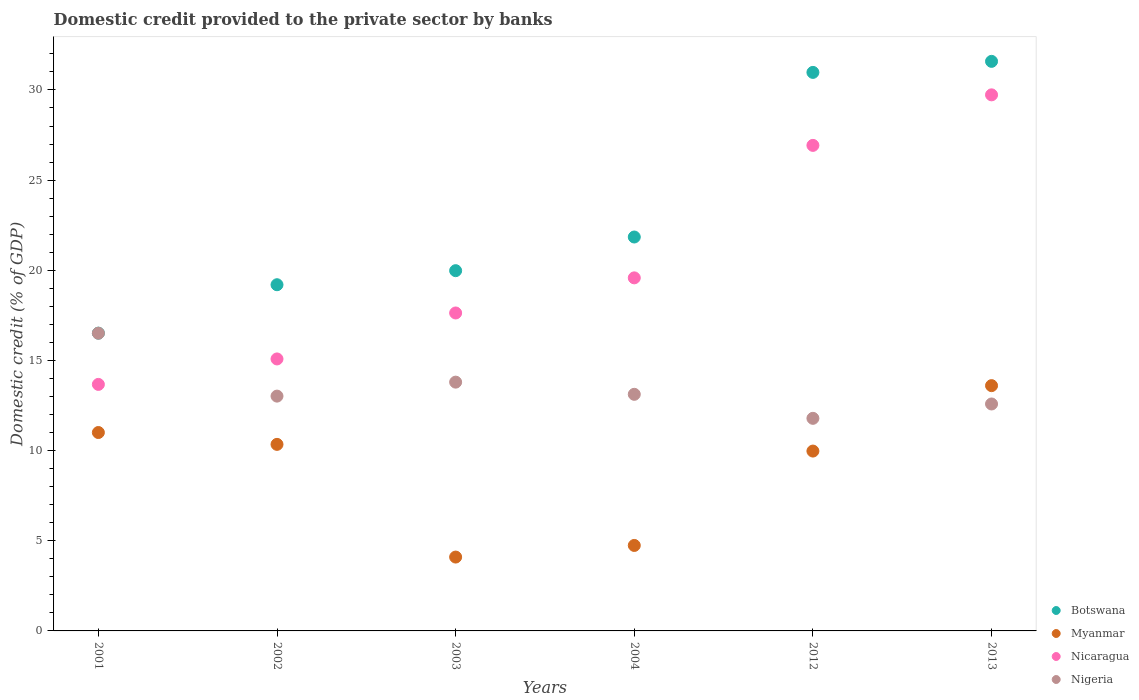Is the number of dotlines equal to the number of legend labels?
Keep it short and to the point. Yes. What is the domestic credit provided to the private sector by banks in Myanmar in 2001?
Provide a short and direct response. 11. Across all years, what is the maximum domestic credit provided to the private sector by banks in Nigeria?
Offer a very short reply. 16.51. Across all years, what is the minimum domestic credit provided to the private sector by banks in Botswana?
Provide a succinct answer. 16.51. In which year was the domestic credit provided to the private sector by banks in Nigeria maximum?
Your answer should be very brief. 2001. What is the total domestic credit provided to the private sector by banks in Nicaragua in the graph?
Your answer should be compact. 122.62. What is the difference between the domestic credit provided to the private sector by banks in Botswana in 2001 and that in 2004?
Your answer should be very brief. -5.33. What is the difference between the domestic credit provided to the private sector by banks in Botswana in 2004 and the domestic credit provided to the private sector by banks in Nicaragua in 2012?
Offer a terse response. -5.08. What is the average domestic credit provided to the private sector by banks in Nicaragua per year?
Your answer should be compact. 20.44. In the year 2001, what is the difference between the domestic credit provided to the private sector by banks in Botswana and domestic credit provided to the private sector by banks in Myanmar?
Provide a short and direct response. 5.51. In how many years, is the domestic credit provided to the private sector by banks in Myanmar greater than 31 %?
Provide a short and direct response. 0. What is the ratio of the domestic credit provided to the private sector by banks in Botswana in 2002 to that in 2003?
Provide a short and direct response. 0.96. Is the difference between the domestic credit provided to the private sector by banks in Botswana in 2004 and 2013 greater than the difference between the domestic credit provided to the private sector by banks in Myanmar in 2004 and 2013?
Ensure brevity in your answer.  No. What is the difference between the highest and the second highest domestic credit provided to the private sector by banks in Nicaragua?
Offer a very short reply. 2.8. What is the difference between the highest and the lowest domestic credit provided to the private sector by banks in Nicaragua?
Offer a terse response. 16.06. Is it the case that in every year, the sum of the domestic credit provided to the private sector by banks in Nigeria and domestic credit provided to the private sector by banks in Myanmar  is greater than the sum of domestic credit provided to the private sector by banks in Nicaragua and domestic credit provided to the private sector by banks in Botswana?
Provide a succinct answer. No. Is it the case that in every year, the sum of the domestic credit provided to the private sector by banks in Nigeria and domestic credit provided to the private sector by banks in Botswana  is greater than the domestic credit provided to the private sector by banks in Nicaragua?
Ensure brevity in your answer.  Yes. Does the domestic credit provided to the private sector by banks in Nicaragua monotonically increase over the years?
Your answer should be very brief. Yes. Is the domestic credit provided to the private sector by banks in Botswana strictly greater than the domestic credit provided to the private sector by banks in Myanmar over the years?
Ensure brevity in your answer.  Yes. Is the domestic credit provided to the private sector by banks in Myanmar strictly less than the domestic credit provided to the private sector by banks in Nigeria over the years?
Provide a short and direct response. No. How many dotlines are there?
Keep it short and to the point. 4. How many years are there in the graph?
Provide a short and direct response. 6. What is the difference between two consecutive major ticks on the Y-axis?
Give a very brief answer. 5. Are the values on the major ticks of Y-axis written in scientific E-notation?
Your response must be concise. No. How many legend labels are there?
Offer a terse response. 4. How are the legend labels stacked?
Your answer should be very brief. Vertical. What is the title of the graph?
Provide a succinct answer. Domestic credit provided to the private sector by banks. Does "American Samoa" appear as one of the legend labels in the graph?
Offer a terse response. No. What is the label or title of the X-axis?
Your answer should be compact. Years. What is the label or title of the Y-axis?
Your answer should be compact. Domestic credit (% of GDP). What is the Domestic credit (% of GDP) of Botswana in 2001?
Provide a succinct answer. 16.51. What is the Domestic credit (% of GDP) of Myanmar in 2001?
Make the answer very short. 11. What is the Domestic credit (% of GDP) in Nicaragua in 2001?
Make the answer very short. 13.67. What is the Domestic credit (% of GDP) of Nigeria in 2001?
Give a very brief answer. 16.51. What is the Domestic credit (% of GDP) of Botswana in 2002?
Provide a succinct answer. 19.2. What is the Domestic credit (% of GDP) in Myanmar in 2002?
Provide a short and direct response. 10.34. What is the Domestic credit (% of GDP) of Nicaragua in 2002?
Offer a terse response. 15.08. What is the Domestic credit (% of GDP) in Nigeria in 2002?
Offer a very short reply. 13.02. What is the Domestic credit (% of GDP) in Botswana in 2003?
Keep it short and to the point. 19.98. What is the Domestic credit (% of GDP) of Myanmar in 2003?
Your answer should be very brief. 4.1. What is the Domestic credit (% of GDP) in Nicaragua in 2003?
Offer a very short reply. 17.63. What is the Domestic credit (% of GDP) in Nigeria in 2003?
Provide a succinct answer. 13.8. What is the Domestic credit (% of GDP) of Botswana in 2004?
Your response must be concise. 21.84. What is the Domestic credit (% of GDP) in Myanmar in 2004?
Your answer should be compact. 4.74. What is the Domestic credit (% of GDP) of Nicaragua in 2004?
Ensure brevity in your answer.  19.58. What is the Domestic credit (% of GDP) in Nigeria in 2004?
Provide a short and direct response. 13.12. What is the Domestic credit (% of GDP) of Botswana in 2012?
Ensure brevity in your answer.  30.97. What is the Domestic credit (% of GDP) in Myanmar in 2012?
Your response must be concise. 9.97. What is the Domestic credit (% of GDP) in Nicaragua in 2012?
Ensure brevity in your answer.  26.93. What is the Domestic credit (% of GDP) of Nigeria in 2012?
Give a very brief answer. 11.79. What is the Domestic credit (% of GDP) in Botswana in 2013?
Your answer should be very brief. 31.58. What is the Domestic credit (% of GDP) in Myanmar in 2013?
Your answer should be very brief. 13.6. What is the Domestic credit (% of GDP) of Nicaragua in 2013?
Keep it short and to the point. 29.73. What is the Domestic credit (% of GDP) in Nigeria in 2013?
Your response must be concise. 12.59. Across all years, what is the maximum Domestic credit (% of GDP) in Botswana?
Offer a very short reply. 31.58. Across all years, what is the maximum Domestic credit (% of GDP) in Myanmar?
Your response must be concise. 13.6. Across all years, what is the maximum Domestic credit (% of GDP) in Nicaragua?
Offer a very short reply. 29.73. Across all years, what is the maximum Domestic credit (% of GDP) in Nigeria?
Give a very brief answer. 16.51. Across all years, what is the minimum Domestic credit (% of GDP) of Botswana?
Provide a succinct answer. 16.51. Across all years, what is the minimum Domestic credit (% of GDP) of Myanmar?
Keep it short and to the point. 4.1. Across all years, what is the minimum Domestic credit (% of GDP) in Nicaragua?
Provide a short and direct response. 13.67. Across all years, what is the minimum Domestic credit (% of GDP) in Nigeria?
Ensure brevity in your answer.  11.79. What is the total Domestic credit (% of GDP) of Botswana in the graph?
Your answer should be compact. 140.09. What is the total Domestic credit (% of GDP) of Myanmar in the graph?
Ensure brevity in your answer.  53.76. What is the total Domestic credit (% of GDP) of Nicaragua in the graph?
Your answer should be compact. 122.62. What is the total Domestic credit (% of GDP) in Nigeria in the graph?
Provide a succinct answer. 80.82. What is the difference between the Domestic credit (% of GDP) of Botswana in 2001 and that in 2002?
Your answer should be very brief. -2.69. What is the difference between the Domestic credit (% of GDP) in Myanmar in 2001 and that in 2002?
Provide a succinct answer. 0.66. What is the difference between the Domestic credit (% of GDP) of Nicaragua in 2001 and that in 2002?
Give a very brief answer. -1.41. What is the difference between the Domestic credit (% of GDP) in Nigeria in 2001 and that in 2002?
Ensure brevity in your answer.  3.49. What is the difference between the Domestic credit (% of GDP) in Botswana in 2001 and that in 2003?
Your response must be concise. -3.47. What is the difference between the Domestic credit (% of GDP) of Myanmar in 2001 and that in 2003?
Make the answer very short. 6.91. What is the difference between the Domestic credit (% of GDP) of Nicaragua in 2001 and that in 2003?
Make the answer very short. -3.96. What is the difference between the Domestic credit (% of GDP) of Nigeria in 2001 and that in 2003?
Give a very brief answer. 2.71. What is the difference between the Domestic credit (% of GDP) in Botswana in 2001 and that in 2004?
Keep it short and to the point. -5.33. What is the difference between the Domestic credit (% of GDP) of Myanmar in 2001 and that in 2004?
Provide a short and direct response. 6.26. What is the difference between the Domestic credit (% of GDP) in Nicaragua in 2001 and that in 2004?
Give a very brief answer. -5.91. What is the difference between the Domestic credit (% of GDP) of Nigeria in 2001 and that in 2004?
Your response must be concise. 3.39. What is the difference between the Domestic credit (% of GDP) of Botswana in 2001 and that in 2012?
Keep it short and to the point. -14.46. What is the difference between the Domestic credit (% of GDP) in Myanmar in 2001 and that in 2012?
Your answer should be very brief. 1.03. What is the difference between the Domestic credit (% of GDP) in Nicaragua in 2001 and that in 2012?
Ensure brevity in your answer.  -13.25. What is the difference between the Domestic credit (% of GDP) in Nigeria in 2001 and that in 2012?
Your answer should be very brief. 4.72. What is the difference between the Domestic credit (% of GDP) of Botswana in 2001 and that in 2013?
Your answer should be very brief. -15.07. What is the difference between the Domestic credit (% of GDP) in Myanmar in 2001 and that in 2013?
Your answer should be compact. -2.6. What is the difference between the Domestic credit (% of GDP) of Nicaragua in 2001 and that in 2013?
Offer a terse response. -16.06. What is the difference between the Domestic credit (% of GDP) of Nigeria in 2001 and that in 2013?
Keep it short and to the point. 3.92. What is the difference between the Domestic credit (% of GDP) in Botswana in 2002 and that in 2003?
Your answer should be compact. -0.78. What is the difference between the Domestic credit (% of GDP) of Myanmar in 2002 and that in 2003?
Give a very brief answer. 6.25. What is the difference between the Domestic credit (% of GDP) in Nicaragua in 2002 and that in 2003?
Offer a terse response. -2.55. What is the difference between the Domestic credit (% of GDP) of Nigeria in 2002 and that in 2003?
Your answer should be compact. -0.78. What is the difference between the Domestic credit (% of GDP) in Botswana in 2002 and that in 2004?
Offer a terse response. -2.65. What is the difference between the Domestic credit (% of GDP) in Myanmar in 2002 and that in 2004?
Make the answer very short. 5.6. What is the difference between the Domestic credit (% of GDP) of Nicaragua in 2002 and that in 2004?
Your answer should be compact. -4.5. What is the difference between the Domestic credit (% of GDP) of Nigeria in 2002 and that in 2004?
Your answer should be compact. -0.1. What is the difference between the Domestic credit (% of GDP) in Botswana in 2002 and that in 2012?
Provide a short and direct response. -11.77. What is the difference between the Domestic credit (% of GDP) in Myanmar in 2002 and that in 2012?
Your answer should be very brief. 0.37. What is the difference between the Domestic credit (% of GDP) in Nicaragua in 2002 and that in 2012?
Offer a terse response. -11.84. What is the difference between the Domestic credit (% of GDP) in Nigeria in 2002 and that in 2012?
Offer a very short reply. 1.23. What is the difference between the Domestic credit (% of GDP) in Botswana in 2002 and that in 2013?
Provide a short and direct response. -12.39. What is the difference between the Domestic credit (% of GDP) in Myanmar in 2002 and that in 2013?
Ensure brevity in your answer.  -3.26. What is the difference between the Domestic credit (% of GDP) in Nicaragua in 2002 and that in 2013?
Ensure brevity in your answer.  -14.64. What is the difference between the Domestic credit (% of GDP) in Nigeria in 2002 and that in 2013?
Provide a short and direct response. 0.44. What is the difference between the Domestic credit (% of GDP) of Botswana in 2003 and that in 2004?
Give a very brief answer. -1.87. What is the difference between the Domestic credit (% of GDP) of Myanmar in 2003 and that in 2004?
Your response must be concise. -0.64. What is the difference between the Domestic credit (% of GDP) of Nicaragua in 2003 and that in 2004?
Your response must be concise. -1.95. What is the difference between the Domestic credit (% of GDP) in Nigeria in 2003 and that in 2004?
Offer a terse response. 0.68. What is the difference between the Domestic credit (% of GDP) of Botswana in 2003 and that in 2012?
Keep it short and to the point. -11. What is the difference between the Domestic credit (% of GDP) in Myanmar in 2003 and that in 2012?
Your response must be concise. -5.88. What is the difference between the Domestic credit (% of GDP) in Nicaragua in 2003 and that in 2012?
Keep it short and to the point. -9.29. What is the difference between the Domestic credit (% of GDP) of Nigeria in 2003 and that in 2012?
Your answer should be compact. 2.01. What is the difference between the Domestic credit (% of GDP) of Botswana in 2003 and that in 2013?
Give a very brief answer. -11.61. What is the difference between the Domestic credit (% of GDP) of Myanmar in 2003 and that in 2013?
Your answer should be compact. -9.51. What is the difference between the Domestic credit (% of GDP) in Nicaragua in 2003 and that in 2013?
Offer a terse response. -12.1. What is the difference between the Domestic credit (% of GDP) in Nigeria in 2003 and that in 2013?
Make the answer very short. 1.21. What is the difference between the Domestic credit (% of GDP) of Botswana in 2004 and that in 2012?
Your answer should be very brief. -9.13. What is the difference between the Domestic credit (% of GDP) in Myanmar in 2004 and that in 2012?
Your response must be concise. -5.23. What is the difference between the Domestic credit (% of GDP) of Nicaragua in 2004 and that in 2012?
Make the answer very short. -7.35. What is the difference between the Domestic credit (% of GDP) of Nigeria in 2004 and that in 2012?
Provide a short and direct response. 1.33. What is the difference between the Domestic credit (% of GDP) of Botswana in 2004 and that in 2013?
Your answer should be compact. -9.74. What is the difference between the Domestic credit (% of GDP) of Myanmar in 2004 and that in 2013?
Ensure brevity in your answer.  -8.86. What is the difference between the Domestic credit (% of GDP) of Nicaragua in 2004 and that in 2013?
Your answer should be compact. -10.15. What is the difference between the Domestic credit (% of GDP) in Nigeria in 2004 and that in 2013?
Your response must be concise. 0.54. What is the difference between the Domestic credit (% of GDP) of Botswana in 2012 and that in 2013?
Provide a short and direct response. -0.61. What is the difference between the Domestic credit (% of GDP) in Myanmar in 2012 and that in 2013?
Your answer should be compact. -3.63. What is the difference between the Domestic credit (% of GDP) of Nicaragua in 2012 and that in 2013?
Keep it short and to the point. -2.8. What is the difference between the Domestic credit (% of GDP) of Nigeria in 2012 and that in 2013?
Your answer should be very brief. -0.8. What is the difference between the Domestic credit (% of GDP) of Botswana in 2001 and the Domestic credit (% of GDP) of Myanmar in 2002?
Provide a short and direct response. 6.17. What is the difference between the Domestic credit (% of GDP) in Botswana in 2001 and the Domestic credit (% of GDP) in Nicaragua in 2002?
Offer a very short reply. 1.43. What is the difference between the Domestic credit (% of GDP) of Botswana in 2001 and the Domestic credit (% of GDP) of Nigeria in 2002?
Offer a terse response. 3.49. What is the difference between the Domestic credit (% of GDP) of Myanmar in 2001 and the Domestic credit (% of GDP) of Nicaragua in 2002?
Make the answer very short. -4.08. What is the difference between the Domestic credit (% of GDP) in Myanmar in 2001 and the Domestic credit (% of GDP) in Nigeria in 2002?
Offer a very short reply. -2.02. What is the difference between the Domestic credit (% of GDP) of Nicaragua in 2001 and the Domestic credit (% of GDP) of Nigeria in 2002?
Offer a very short reply. 0.65. What is the difference between the Domestic credit (% of GDP) of Botswana in 2001 and the Domestic credit (% of GDP) of Myanmar in 2003?
Offer a very short reply. 12.42. What is the difference between the Domestic credit (% of GDP) in Botswana in 2001 and the Domestic credit (% of GDP) in Nicaragua in 2003?
Offer a very short reply. -1.12. What is the difference between the Domestic credit (% of GDP) of Botswana in 2001 and the Domestic credit (% of GDP) of Nigeria in 2003?
Offer a very short reply. 2.72. What is the difference between the Domestic credit (% of GDP) in Myanmar in 2001 and the Domestic credit (% of GDP) in Nicaragua in 2003?
Provide a short and direct response. -6.63. What is the difference between the Domestic credit (% of GDP) of Myanmar in 2001 and the Domestic credit (% of GDP) of Nigeria in 2003?
Your response must be concise. -2.79. What is the difference between the Domestic credit (% of GDP) of Nicaragua in 2001 and the Domestic credit (% of GDP) of Nigeria in 2003?
Give a very brief answer. -0.13. What is the difference between the Domestic credit (% of GDP) of Botswana in 2001 and the Domestic credit (% of GDP) of Myanmar in 2004?
Ensure brevity in your answer.  11.77. What is the difference between the Domestic credit (% of GDP) in Botswana in 2001 and the Domestic credit (% of GDP) in Nicaragua in 2004?
Offer a very short reply. -3.07. What is the difference between the Domestic credit (% of GDP) in Botswana in 2001 and the Domestic credit (% of GDP) in Nigeria in 2004?
Offer a very short reply. 3.39. What is the difference between the Domestic credit (% of GDP) of Myanmar in 2001 and the Domestic credit (% of GDP) of Nicaragua in 2004?
Make the answer very short. -8.58. What is the difference between the Domestic credit (% of GDP) of Myanmar in 2001 and the Domestic credit (% of GDP) of Nigeria in 2004?
Make the answer very short. -2.12. What is the difference between the Domestic credit (% of GDP) of Nicaragua in 2001 and the Domestic credit (% of GDP) of Nigeria in 2004?
Your answer should be compact. 0.55. What is the difference between the Domestic credit (% of GDP) of Botswana in 2001 and the Domestic credit (% of GDP) of Myanmar in 2012?
Make the answer very short. 6.54. What is the difference between the Domestic credit (% of GDP) in Botswana in 2001 and the Domestic credit (% of GDP) in Nicaragua in 2012?
Keep it short and to the point. -10.41. What is the difference between the Domestic credit (% of GDP) of Botswana in 2001 and the Domestic credit (% of GDP) of Nigeria in 2012?
Your answer should be compact. 4.72. What is the difference between the Domestic credit (% of GDP) in Myanmar in 2001 and the Domestic credit (% of GDP) in Nicaragua in 2012?
Provide a short and direct response. -15.92. What is the difference between the Domestic credit (% of GDP) of Myanmar in 2001 and the Domestic credit (% of GDP) of Nigeria in 2012?
Offer a terse response. -0.79. What is the difference between the Domestic credit (% of GDP) of Nicaragua in 2001 and the Domestic credit (% of GDP) of Nigeria in 2012?
Offer a terse response. 1.88. What is the difference between the Domestic credit (% of GDP) in Botswana in 2001 and the Domestic credit (% of GDP) in Myanmar in 2013?
Offer a terse response. 2.91. What is the difference between the Domestic credit (% of GDP) of Botswana in 2001 and the Domestic credit (% of GDP) of Nicaragua in 2013?
Provide a succinct answer. -13.22. What is the difference between the Domestic credit (% of GDP) in Botswana in 2001 and the Domestic credit (% of GDP) in Nigeria in 2013?
Offer a terse response. 3.93. What is the difference between the Domestic credit (% of GDP) in Myanmar in 2001 and the Domestic credit (% of GDP) in Nicaragua in 2013?
Keep it short and to the point. -18.73. What is the difference between the Domestic credit (% of GDP) of Myanmar in 2001 and the Domestic credit (% of GDP) of Nigeria in 2013?
Ensure brevity in your answer.  -1.58. What is the difference between the Domestic credit (% of GDP) of Nicaragua in 2001 and the Domestic credit (% of GDP) of Nigeria in 2013?
Offer a terse response. 1.09. What is the difference between the Domestic credit (% of GDP) in Botswana in 2002 and the Domestic credit (% of GDP) in Myanmar in 2003?
Your answer should be very brief. 15.1. What is the difference between the Domestic credit (% of GDP) in Botswana in 2002 and the Domestic credit (% of GDP) in Nicaragua in 2003?
Provide a short and direct response. 1.57. What is the difference between the Domestic credit (% of GDP) of Botswana in 2002 and the Domestic credit (% of GDP) of Nigeria in 2003?
Make the answer very short. 5.4. What is the difference between the Domestic credit (% of GDP) in Myanmar in 2002 and the Domestic credit (% of GDP) in Nicaragua in 2003?
Ensure brevity in your answer.  -7.29. What is the difference between the Domestic credit (% of GDP) in Myanmar in 2002 and the Domestic credit (% of GDP) in Nigeria in 2003?
Provide a succinct answer. -3.45. What is the difference between the Domestic credit (% of GDP) of Nicaragua in 2002 and the Domestic credit (% of GDP) of Nigeria in 2003?
Offer a terse response. 1.29. What is the difference between the Domestic credit (% of GDP) in Botswana in 2002 and the Domestic credit (% of GDP) in Myanmar in 2004?
Keep it short and to the point. 14.46. What is the difference between the Domestic credit (% of GDP) in Botswana in 2002 and the Domestic credit (% of GDP) in Nicaragua in 2004?
Make the answer very short. -0.38. What is the difference between the Domestic credit (% of GDP) in Botswana in 2002 and the Domestic credit (% of GDP) in Nigeria in 2004?
Ensure brevity in your answer.  6.08. What is the difference between the Domestic credit (% of GDP) in Myanmar in 2002 and the Domestic credit (% of GDP) in Nicaragua in 2004?
Ensure brevity in your answer.  -9.23. What is the difference between the Domestic credit (% of GDP) of Myanmar in 2002 and the Domestic credit (% of GDP) of Nigeria in 2004?
Ensure brevity in your answer.  -2.78. What is the difference between the Domestic credit (% of GDP) in Nicaragua in 2002 and the Domestic credit (% of GDP) in Nigeria in 2004?
Offer a very short reply. 1.96. What is the difference between the Domestic credit (% of GDP) of Botswana in 2002 and the Domestic credit (% of GDP) of Myanmar in 2012?
Provide a succinct answer. 9.22. What is the difference between the Domestic credit (% of GDP) in Botswana in 2002 and the Domestic credit (% of GDP) in Nicaragua in 2012?
Your answer should be very brief. -7.73. What is the difference between the Domestic credit (% of GDP) in Botswana in 2002 and the Domestic credit (% of GDP) in Nigeria in 2012?
Your response must be concise. 7.41. What is the difference between the Domestic credit (% of GDP) of Myanmar in 2002 and the Domestic credit (% of GDP) of Nicaragua in 2012?
Provide a succinct answer. -16.58. What is the difference between the Domestic credit (% of GDP) in Myanmar in 2002 and the Domestic credit (% of GDP) in Nigeria in 2012?
Provide a short and direct response. -1.44. What is the difference between the Domestic credit (% of GDP) in Nicaragua in 2002 and the Domestic credit (% of GDP) in Nigeria in 2012?
Provide a short and direct response. 3.29. What is the difference between the Domestic credit (% of GDP) of Botswana in 2002 and the Domestic credit (% of GDP) of Myanmar in 2013?
Offer a terse response. 5.6. What is the difference between the Domestic credit (% of GDP) in Botswana in 2002 and the Domestic credit (% of GDP) in Nicaragua in 2013?
Offer a very short reply. -10.53. What is the difference between the Domestic credit (% of GDP) of Botswana in 2002 and the Domestic credit (% of GDP) of Nigeria in 2013?
Keep it short and to the point. 6.61. What is the difference between the Domestic credit (% of GDP) in Myanmar in 2002 and the Domestic credit (% of GDP) in Nicaragua in 2013?
Your answer should be very brief. -19.38. What is the difference between the Domestic credit (% of GDP) of Myanmar in 2002 and the Domestic credit (% of GDP) of Nigeria in 2013?
Provide a succinct answer. -2.24. What is the difference between the Domestic credit (% of GDP) of Nicaragua in 2002 and the Domestic credit (% of GDP) of Nigeria in 2013?
Provide a succinct answer. 2.5. What is the difference between the Domestic credit (% of GDP) in Botswana in 2003 and the Domestic credit (% of GDP) in Myanmar in 2004?
Your answer should be very brief. 15.24. What is the difference between the Domestic credit (% of GDP) of Botswana in 2003 and the Domestic credit (% of GDP) of Nicaragua in 2004?
Provide a short and direct response. 0.4. What is the difference between the Domestic credit (% of GDP) of Botswana in 2003 and the Domestic credit (% of GDP) of Nigeria in 2004?
Your response must be concise. 6.86. What is the difference between the Domestic credit (% of GDP) in Myanmar in 2003 and the Domestic credit (% of GDP) in Nicaragua in 2004?
Offer a very short reply. -15.48. What is the difference between the Domestic credit (% of GDP) in Myanmar in 2003 and the Domestic credit (% of GDP) in Nigeria in 2004?
Keep it short and to the point. -9.03. What is the difference between the Domestic credit (% of GDP) in Nicaragua in 2003 and the Domestic credit (% of GDP) in Nigeria in 2004?
Ensure brevity in your answer.  4.51. What is the difference between the Domestic credit (% of GDP) in Botswana in 2003 and the Domestic credit (% of GDP) in Myanmar in 2012?
Your response must be concise. 10. What is the difference between the Domestic credit (% of GDP) in Botswana in 2003 and the Domestic credit (% of GDP) in Nicaragua in 2012?
Provide a short and direct response. -6.95. What is the difference between the Domestic credit (% of GDP) of Botswana in 2003 and the Domestic credit (% of GDP) of Nigeria in 2012?
Keep it short and to the point. 8.19. What is the difference between the Domestic credit (% of GDP) of Myanmar in 2003 and the Domestic credit (% of GDP) of Nicaragua in 2012?
Your answer should be compact. -22.83. What is the difference between the Domestic credit (% of GDP) in Myanmar in 2003 and the Domestic credit (% of GDP) in Nigeria in 2012?
Provide a short and direct response. -7.69. What is the difference between the Domestic credit (% of GDP) in Nicaragua in 2003 and the Domestic credit (% of GDP) in Nigeria in 2012?
Provide a short and direct response. 5.84. What is the difference between the Domestic credit (% of GDP) of Botswana in 2003 and the Domestic credit (% of GDP) of Myanmar in 2013?
Keep it short and to the point. 6.38. What is the difference between the Domestic credit (% of GDP) in Botswana in 2003 and the Domestic credit (% of GDP) in Nicaragua in 2013?
Make the answer very short. -9.75. What is the difference between the Domestic credit (% of GDP) of Botswana in 2003 and the Domestic credit (% of GDP) of Nigeria in 2013?
Make the answer very short. 7.39. What is the difference between the Domestic credit (% of GDP) of Myanmar in 2003 and the Domestic credit (% of GDP) of Nicaragua in 2013?
Keep it short and to the point. -25.63. What is the difference between the Domestic credit (% of GDP) of Myanmar in 2003 and the Domestic credit (% of GDP) of Nigeria in 2013?
Provide a succinct answer. -8.49. What is the difference between the Domestic credit (% of GDP) of Nicaragua in 2003 and the Domestic credit (% of GDP) of Nigeria in 2013?
Provide a short and direct response. 5.05. What is the difference between the Domestic credit (% of GDP) in Botswana in 2004 and the Domestic credit (% of GDP) in Myanmar in 2012?
Provide a succinct answer. 11.87. What is the difference between the Domestic credit (% of GDP) in Botswana in 2004 and the Domestic credit (% of GDP) in Nicaragua in 2012?
Your answer should be very brief. -5.08. What is the difference between the Domestic credit (% of GDP) of Botswana in 2004 and the Domestic credit (% of GDP) of Nigeria in 2012?
Give a very brief answer. 10.06. What is the difference between the Domestic credit (% of GDP) in Myanmar in 2004 and the Domestic credit (% of GDP) in Nicaragua in 2012?
Your answer should be compact. -22.19. What is the difference between the Domestic credit (% of GDP) in Myanmar in 2004 and the Domestic credit (% of GDP) in Nigeria in 2012?
Ensure brevity in your answer.  -7.05. What is the difference between the Domestic credit (% of GDP) in Nicaragua in 2004 and the Domestic credit (% of GDP) in Nigeria in 2012?
Offer a very short reply. 7.79. What is the difference between the Domestic credit (% of GDP) in Botswana in 2004 and the Domestic credit (% of GDP) in Myanmar in 2013?
Your response must be concise. 8.24. What is the difference between the Domestic credit (% of GDP) in Botswana in 2004 and the Domestic credit (% of GDP) in Nicaragua in 2013?
Make the answer very short. -7.88. What is the difference between the Domestic credit (% of GDP) in Botswana in 2004 and the Domestic credit (% of GDP) in Nigeria in 2013?
Ensure brevity in your answer.  9.26. What is the difference between the Domestic credit (% of GDP) of Myanmar in 2004 and the Domestic credit (% of GDP) of Nicaragua in 2013?
Ensure brevity in your answer.  -24.99. What is the difference between the Domestic credit (% of GDP) of Myanmar in 2004 and the Domestic credit (% of GDP) of Nigeria in 2013?
Make the answer very short. -7.85. What is the difference between the Domestic credit (% of GDP) of Nicaragua in 2004 and the Domestic credit (% of GDP) of Nigeria in 2013?
Give a very brief answer. 6.99. What is the difference between the Domestic credit (% of GDP) in Botswana in 2012 and the Domestic credit (% of GDP) in Myanmar in 2013?
Give a very brief answer. 17.37. What is the difference between the Domestic credit (% of GDP) in Botswana in 2012 and the Domestic credit (% of GDP) in Nicaragua in 2013?
Your answer should be compact. 1.25. What is the difference between the Domestic credit (% of GDP) in Botswana in 2012 and the Domestic credit (% of GDP) in Nigeria in 2013?
Your answer should be compact. 18.39. What is the difference between the Domestic credit (% of GDP) in Myanmar in 2012 and the Domestic credit (% of GDP) in Nicaragua in 2013?
Your response must be concise. -19.75. What is the difference between the Domestic credit (% of GDP) of Myanmar in 2012 and the Domestic credit (% of GDP) of Nigeria in 2013?
Your answer should be compact. -2.61. What is the difference between the Domestic credit (% of GDP) in Nicaragua in 2012 and the Domestic credit (% of GDP) in Nigeria in 2013?
Keep it short and to the point. 14.34. What is the average Domestic credit (% of GDP) of Botswana per year?
Offer a very short reply. 23.35. What is the average Domestic credit (% of GDP) of Myanmar per year?
Keep it short and to the point. 8.96. What is the average Domestic credit (% of GDP) of Nicaragua per year?
Your response must be concise. 20.44. What is the average Domestic credit (% of GDP) of Nigeria per year?
Ensure brevity in your answer.  13.47. In the year 2001, what is the difference between the Domestic credit (% of GDP) in Botswana and Domestic credit (% of GDP) in Myanmar?
Keep it short and to the point. 5.51. In the year 2001, what is the difference between the Domestic credit (% of GDP) of Botswana and Domestic credit (% of GDP) of Nicaragua?
Provide a succinct answer. 2.84. In the year 2001, what is the difference between the Domestic credit (% of GDP) of Botswana and Domestic credit (% of GDP) of Nigeria?
Ensure brevity in your answer.  0. In the year 2001, what is the difference between the Domestic credit (% of GDP) in Myanmar and Domestic credit (% of GDP) in Nicaragua?
Your answer should be very brief. -2.67. In the year 2001, what is the difference between the Domestic credit (% of GDP) in Myanmar and Domestic credit (% of GDP) in Nigeria?
Provide a succinct answer. -5.51. In the year 2001, what is the difference between the Domestic credit (% of GDP) in Nicaragua and Domestic credit (% of GDP) in Nigeria?
Make the answer very short. -2.84. In the year 2002, what is the difference between the Domestic credit (% of GDP) in Botswana and Domestic credit (% of GDP) in Myanmar?
Offer a terse response. 8.85. In the year 2002, what is the difference between the Domestic credit (% of GDP) in Botswana and Domestic credit (% of GDP) in Nicaragua?
Make the answer very short. 4.12. In the year 2002, what is the difference between the Domestic credit (% of GDP) of Botswana and Domestic credit (% of GDP) of Nigeria?
Provide a short and direct response. 6.18. In the year 2002, what is the difference between the Domestic credit (% of GDP) in Myanmar and Domestic credit (% of GDP) in Nicaragua?
Ensure brevity in your answer.  -4.74. In the year 2002, what is the difference between the Domestic credit (% of GDP) of Myanmar and Domestic credit (% of GDP) of Nigeria?
Offer a terse response. -2.68. In the year 2002, what is the difference between the Domestic credit (% of GDP) in Nicaragua and Domestic credit (% of GDP) in Nigeria?
Keep it short and to the point. 2.06. In the year 2003, what is the difference between the Domestic credit (% of GDP) of Botswana and Domestic credit (% of GDP) of Myanmar?
Give a very brief answer. 15.88. In the year 2003, what is the difference between the Domestic credit (% of GDP) in Botswana and Domestic credit (% of GDP) in Nicaragua?
Your response must be concise. 2.35. In the year 2003, what is the difference between the Domestic credit (% of GDP) in Botswana and Domestic credit (% of GDP) in Nigeria?
Your answer should be very brief. 6.18. In the year 2003, what is the difference between the Domestic credit (% of GDP) in Myanmar and Domestic credit (% of GDP) in Nicaragua?
Provide a succinct answer. -13.54. In the year 2003, what is the difference between the Domestic credit (% of GDP) of Myanmar and Domestic credit (% of GDP) of Nigeria?
Offer a terse response. -9.7. In the year 2003, what is the difference between the Domestic credit (% of GDP) of Nicaragua and Domestic credit (% of GDP) of Nigeria?
Your answer should be compact. 3.84. In the year 2004, what is the difference between the Domestic credit (% of GDP) of Botswana and Domestic credit (% of GDP) of Myanmar?
Keep it short and to the point. 17.1. In the year 2004, what is the difference between the Domestic credit (% of GDP) in Botswana and Domestic credit (% of GDP) in Nicaragua?
Your response must be concise. 2.27. In the year 2004, what is the difference between the Domestic credit (% of GDP) in Botswana and Domestic credit (% of GDP) in Nigeria?
Your answer should be compact. 8.72. In the year 2004, what is the difference between the Domestic credit (% of GDP) of Myanmar and Domestic credit (% of GDP) of Nicaragua?
Offer a terse response. -14.84. In the year 2004, what is the difference between the Domestic credit (% of GDP) of Myanmar and Domestic credit (% of GDP) of Nigeria?
Make the answer very short. -8.38. In the year 2004, what is the difference between the Domestic credit (% of GDP) in Nicaragua and Domestic credit (% of GDP) in Nigeria?
Your answer should be compact. 6.46. In the year 2012, what is the difference between the Domestic credit (% of GDP) of Botswana and Domestic credit (% of GDP) of Myanmar?
Your answer should be very brief. 21. In the year 2012, what is the difference between the Domestic credit (% of GDP) of Botswana and Domestic credit (% of GDP) of Nicaragua?
Ensure brevity in your answer.  4.05. In the year 2012, what is the difference between the Domestic credit (% of GDP) of Botswana and Domestic credit (% of GDP) of Nigeria?
Provide a short and direct response. 19.18. In the year 2012, what is the difference between the Domestic credit (% of GDP) of Myanmar and Domestic credit (% of GDP) of Nicaragua?
Your answer should be compact. -16.95. In the year 2012, what is the difference between the Domestic credit (% of GDP) of Myanmar and Domestic credit (% of GDP) of Nigeria?
Give a very brief answer. -1.82. In the year 2012, what is the difference between the Domestic credit (% of GDP) of Nicaragua and Domestic credit (% of GDP) of Nigeria?
Offer a terse response. 15.14. In the year 2013, what is the difference between the Domestic credit (% of GDP) of Botswana and Domestic credit (% of GDP) of Myanmar?
Your answer should be very brief. 17.98. In the year 2013, what is the difference between the Domestic credit (% of GDP) of Botswana and Domestic credit (% of GDP) of Nicaragua?
Keep it short and to the point. 1.86. In the year 2013, what is the difference between the Domestic credit (% of GDP) in Botswana and Domestic credit (% of GDP) in Nigeria?
Your response must be concise. 19. In the year 2013, what is the difference between the Domestic credit (% of GDP) in Myanmar and Domestic credit (% of GDP) in Nicaragua?
Provide a succinct answer. -16.13. In the year 2013, what is the difference between the Domestic credit (% of GDP) in Myanmar and Domestic credit (% of GDP) in Nigeria?
Your response must be concise. 1.02. In the year 2013, what is the difference between the Domestic credit (% of GDP) of Nicaragua and Domestic credit (% of GDP) of Nigeria?
Your answer should be compact. 17.14. What is the ratio of the Domestic credit (% of GDP) in Botswana in 2001 to that in 2002?
Make the answer very short. 0.86. What is the ratio of the Domestic credit (% of GDP) in Myanmar in 2001 to that in 2002?
Provide a short and direct response. 1.06. What is the ratio of the Domestic credit (% of GDP) of Nicaragua in 2001 to that in 2002?
Provide a succinct answer. 0.91. What is the ratio of the Domestic credit (% of GDP) in Nigeria in 2001 to that in 2002?
Offer a terse response. 1.27. What is the ratio of the Domestic credit (% of GDP) in Botswana in 2001 to that in 2003?
Give a very brief answer. 0.83. What is the ratio of the Domestic credit (% of GDP) of Myanmar in 2001 to that in 2003?
Offer a terse response. 2.69. What is the ratio of the Domestic credit (% of GDP) of Nicaragua in 2001 to that in 2003?
Your response must be concise. 0.78. What is the ratio of the Domestic credit (% of GDP) in Nigeria in 2001 to that in 2003?
Offer a very short reply. 1.2. What is the ratio of the Domestic credit (% of GDP) in Botswana in 2001 to that in 2004?
Your answer should be compact. 0.76. What is the ratio of the Domestic credit (% of GDP) in Myanmar in 2001 to that in 2004?
Give a very brief answer. 2.32. What is the ratio of the Domestic credit (% of GDP) of Nicaragua in 2001 to that in 2004?
Provide a short and direct response. 0.7. What is the ratio of the Domestic credit (% of GDP) in Nigeria in 2001 to that in 2004?
Provide a short and direct response. 1.26. What is the ratio of the Domestic credit (% of GDP) in Botswana in 2001 to that in 2012?
Provide a succinct answer. 0.53. What is the ratio of the Domestic credit (% of GDP) of Myanmar in 2001 to that in 2012?
Your answer should be compact. 1.1. What is the ratio of the Domestic credit (% of GDP) of Nicaragua in 2001 to that in 2012?
Your answer should be compact. 0.51. What is the ratio of the Domestic credit (% of GDP) of Nigeria in 2001 to that in 2012?
Offer a terse response. 1.4. What is the ratio of the Domestic credit (% of GDP) of Botswana in 2001 to that in 2013?
Make the answer very short. 0.52. What is the ratio of the Domestic credit (% of GDP) in Myanmar in 2001 to that in 2013?
Your answer should be compact. 0.81. What is the ratio of the Domestic credit (% of GDP) of Nicaragua in 2001 to that in 2013?
Provide a succinct answer. 0.46. What is the ratio of the Domestic credit (% of GDP) of Nigeria in 2001 to that in 2013?
Offer a very short reply. 1.31. What is the ratio of the Domestic credit (% of GDP) of Botswana in 2002 to that in 2003?
Ensure brevity in your answer.  0.96. What is the ratio of the Domestic credit (% of GDP) in Myanmar in 2002 to that in 2003?
Your response must be concise. 2.53. What is the ratio of the Domestic credit (% of GDP) in Nicaragua in 2002 to that in 2003?
Provide a succinct answer. 0.86. What is the ratio of the Domestic credit (% of GDP) of Nigeria in 2002 to that in 2003?
Provide a short and direct response. 0.94. What is the ratio of the Domestic credit (% of GDP) in Botswana in 2002 to that in 2004?
Provide a succinct answer. 0.88. What is the ratio of the Domestic credit (% of GDP) in Myanmar in 2002 to that in 2004?
Your response must be concise. 2.18. What is the ratio of the Domestic credit (% of GDP) in Nicaragua in 2002 to that in 2004?
Provide a succinct answer. 0.77. What is the ratio of the Domestic credit (% of GDP) in Nigeria in 2002 to that in 2004?
Your response must be concise. 0.99. What is the ratio of the Domestic credit (% of GDP) in Botswana in 2002 to that in 2012?
Offer a terse response. 0.62. What is the ratio of the Domestic credit (% of GDP) in Myanmar in 2002 to that in 2012?
Give a very brief answer. 1.04. What is the ratio of the Domestic credit (% of GDP) of Nicaragua in 2002 to that in 2012?
Keep it short and to the point. 0.56. What is the ratio of the Domestic credit (% of GDP) in Nigeria in 2002 to that in 2012?
Ensure brevity in your answer.  1.1. What is the ratio of the Domestic credit (% of GDP) of Botswana in 2002 to that in 2013?
Provide a succinct answer. 0.61. What is the ratio of the Domestic credit (% of GDP) in Myanmar in 2002 to that in 2013?
Keep it short and to the point. 0.76. What is the ratio of the Domestic credit (% of GDP) of Nicaragua in 2002 to that in 2013?
Make the answer very short. 0.51. What is the ratio of the Domestic credit (% of GDP) in Nigeria in 2002 to that in 2013?
Keep it short and to the point. 1.03. What is the ratio of the Domestic credit (% of GDP) of Botswana in 2003 to that in 2004?
Your response must be concise. 0.91. What is the ratio of the Domestic credit (% of GDP) in Myanmar in 2003 to that in 2004?
Provide a short and direct response. 0.86. What is the ratio of the Domestic credit (% of GDP) in Nicaragua in 2003 to that in 2004?
Make the answer very short. 0.9. What is the ratio of the Domestic credit (% of GDP) in Nigeria in 2003 to that in 2004?
Your answer should be compact. 1.05. What is the ratio of the Domestic credit (% of GDP) in Botswana in 2003 to that in 2012?
Your answer should be compact. 0.65. What is the ratio of the Domestic credit (% of GDP) of Myanmar in 2003 to that in 2012?
Keep it short and to the point. 0.41. What is the ratio of the Domestic credit (% of GDP) in Nicaragua in 2003 to that in 2012?
Your answer should be compact. 0.65. What is the ratio of the Domestic credit (% of GDP) of Nigeria in 2003 to that in 2012?
Give a very brief answer. 1.17. What is the ratio of the Domestic credit (% of GDP) in Botswana in 2003 to that in 2013?
Provide a succinct answer. 0.63. What is the ratio of the Domestic credit (% of GDP) of Myanmar in 2003 to that in 2013?
Ensure brevity in your answer.  0.3. What is the ratio of the Domestic credit (% of GDP) in Nicaragua in 2003 to that in 2013?
Make the answer very short. 0.59. What is the ratio of the Domestic credit (% of GDP) in Nigeria in 2003 to that in 2013?
Offer a very short reply. 1.1. What is the ratio of the Domestic credit (% of GDP) in Botswana in 2004 to that in 2012?
Provide a short and direct response. 0.71. What is the ratio of the Domestic credit (% of GDP) in Myanmar in 2004 to that in 2012?
Provide a short and direct response. 0.48. What is the ratio of the Domestic credit (% of GDP) of Nicaragua in 2004 to that in 2012?
Ensure brevity in your answer.  0.73. What is the ratio of the Domestic credit (% of GDP) in Nigeria in 2004 to that in 2012?
Make the answer very short. 1.11. What is the ratio of the Domestic credit (% of GDP) of Botswana in 2004 to that in 2013?
Your response must be concise. 0.69. What is the ratio of the Domestic credit (% of GDP) in Myanmar in 2004 to that in 2013?
Your answer should be compact. 0.35. What is the ratio of the Domestic credit (% of GDP) in Nicaragua in 2004 to that in 2013?
Ensure brevity in your answer.  0.66. What is the ratio of the Domestic credit (% of GDP) of Nigeria in 2004 to that in 2013?
Give a very brief answer. 1.04. What is the ratio of the Domestic credit (% of GDP) of Botswana in 2012 to that in 2013?
Your response must be concise. 0.98. What is the ratio of the Domestic credit (% of GDP) in Myanmar in 2012 to that in 2013?
Offer a very short reply. 0.73. What is the ratio of the Domestic credit (% of GDP) in Nicaragua in 2012 to that in 2013?
Offer a very short reply. 0.91. What is the ratio of the Domestic credit (% of GDP) of Nigeria in 2012 to that in 2013?
Provide a succinct answer. 0.94. What is the difference between the highest and the second highest Domestic credit (% of GDP) of Botswana?
Offer a terse response. 0.61. What is the difference between the highest and the second highest Domestic credit (% of GDP) of Myanmar?
Offer a terse response. 2.6. What is the difference between the highest and the second highest Domestic credit (% of GDP) in Nicaragua?
Give a very brief answer. 2.8. What is the difference between the highest and the second highest Domestic credit (% of GDP) in Nigeria?
Provide a short and direct response. 2.71. What is the difference between the highest and the lowest Domestic credit (% of GDP) of Botswana?
Your answer should be very brief. 15.07. What is the difference between the highest and the lowest Domestic credit (% of GDP) in Myanmar?
Offer a terse response. 9.51. What is the difference between the highest and the lowest Domestic credit (% of GDP) of Nicaragua?
Your answer should be very brief. 16.06. What is the difference between the highest and the lowest Domestic credit (% of GDP) in Nigeria?
Provide a succinct answer. 4.72. 